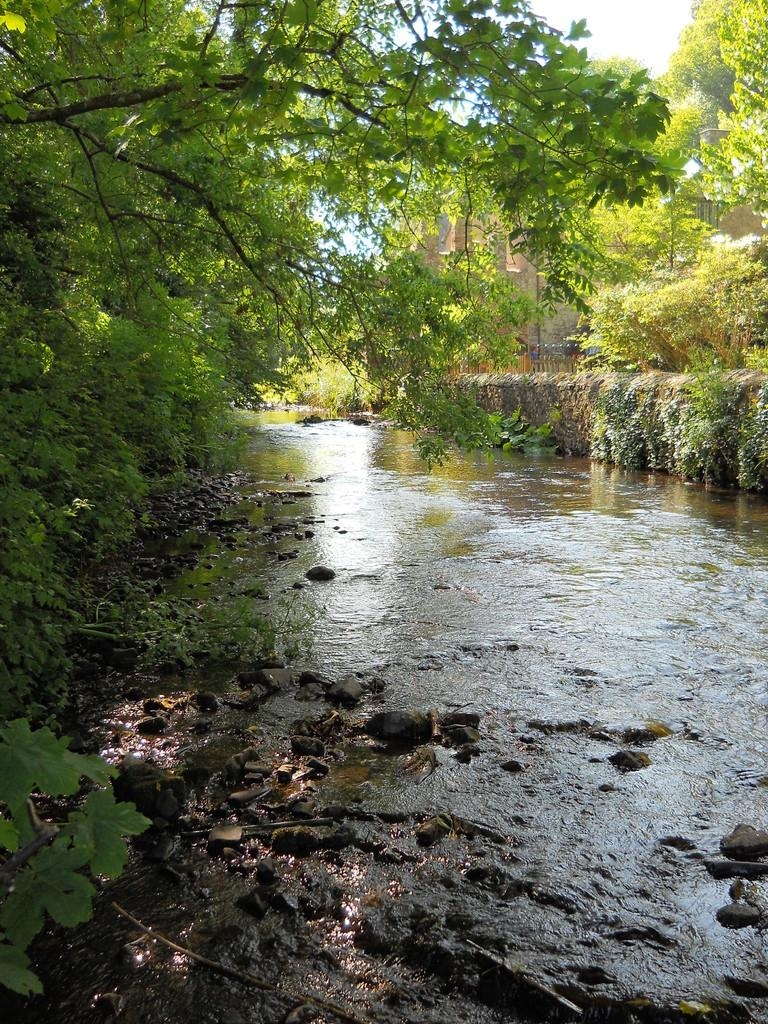What body of water is present in the image? There is a lake in the image. What type of vegetation is near the lake? There are trees beside the lake. What type of structure is visible in the image? There is a building in the image. How many beds are visible in the image? There are no beds present in the image. 